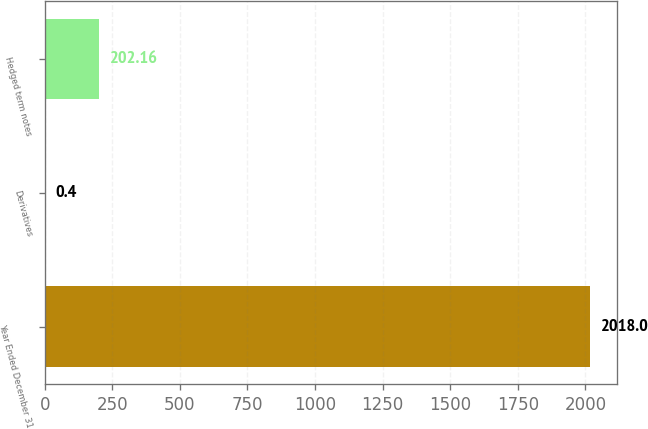Convert chart to OTSL. <chart><loc_0><loc_0><loc_500><loc_500><bar_chart><fcel>Year Ended December 31<fcel>Derivatives<fcel>Hedged term notes<nl><fcel>2018<fcel>0.4<fcel>202.16<nl></chart> 